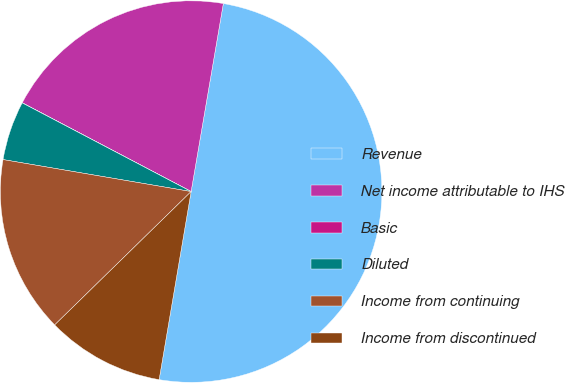Convert chart. <chart><loc_0><loc_0><loc_500><loc_500><pie_chart><fcel>Revenue<fcel>Net income attributable to IHS<fcel>Basic<fcel>Diluted<fcel>Income from continuing<fcel>Income from discontinued<nl><fcel>49.98%<fcel>20.0%<fcel>0.01%<fcel>5.01%<fcel>15.0%<fcel>10.0%<nl></chart> 